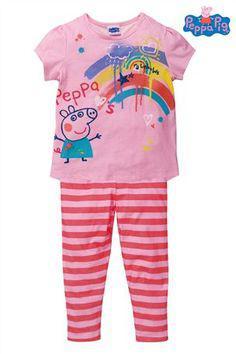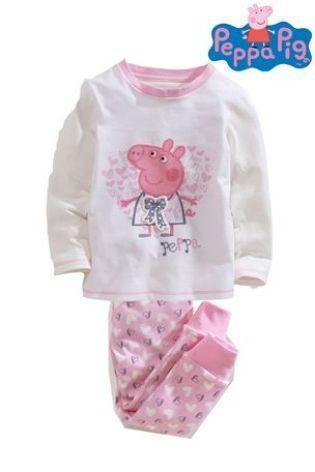The first image is the image on the left, the second image is the image on the right. Examine the images to the left and right. Is the description "Clothing is being modeled by children in each of the images." accurate? Answer yes or no. No. The first image is the image on the left, the second image is the image on the right. Considering the images on both sides, is "Some outfits feature a pink cartoon pig, and each image contains exactly two sleepwear outfits." valid? Answer yes or no. No. 